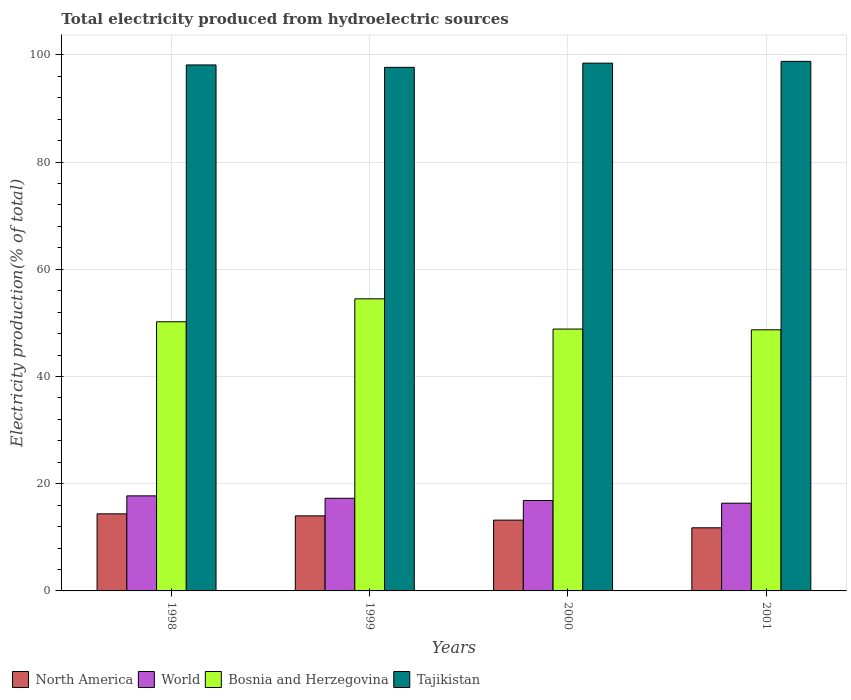How many different coloured bars are there?
Provide a succinct answer. 4. How many groups of bars are there?
Offer a very short reply. 4. How many bars are there on the 1st tick from the left?
Keep it short and to the point. 4. How many bars are there on the 1st tick from the right?
Your answer should be compact. 4. What is the label of the 2nd group of bars from the left?
Make the answer very short. 1999. What is the total electricity produced in Bosnia and Herzegovina in 2001?
Give a very brief answer. 48.7. Across all years, what is the maximum total electricity produced in Tajikistan?
Make the answer very short. 98.78. Across all years, what is the minimum total electricity produced in North America?
Keep it short and to the point. 11.77. What is the total total electricity produced in World in the graph?
Ensure brevity in your answer.  68.24. What is the difference between the total electricity produced in North America in 1999 and that in 2001?
Offer a terse response. 2.23. What is the difference between the total electricity produced in Bosnia and Herzegovina in 1998 and the total electricity produced in North America in 2001?
Provide a succinct answer. 38.43. What is the average total electricity produced in North America per year?
Your response must be concise. 13.34. In the year 1998, what is the difference between the total electricity produced in Bosnia and Herzegovina and total electricity produced in World?
Keep it short and to the point. 32.47. What is the ratio of the total electricity produced in North America in 2000 to that in 2001?
Ensure brevity in your answer.  1.12. Is the total electricity produced in World in 2000 less than that in 2001?
Your answer should be very brief. No. What is the difference between the highest and the second highest total electricity produced in World?
Provide a short and direct response. 0.45. What is the difference between the highest and the lowest total electricity produced in North America?
Keep it short and to the point. 2.6. In how many years, is the total electricity produced in North America greater than the average total electricity produced in North America taken over all years?
Ensure brevity in your answer.  2. Is the sum of the total electricity produced in Bosnia and Herzegovina in 1998 and 2000 greater than the maximum total electricity produced in Tajikistan across all years?
Your answer should be compact. Yes. Is it the case that in every year, the sum of the total electricity produced in Bosnia and Herzegovina and total electricity produced in World is greater than the sum of total electricity produced in North America and total electricity produced in Tajikistan?
Provide a short and direct response. Yes. What does the 4th bar from the left in 2001 represents?
Your answer should be very brief. Tajikistan. Are all the bars in the graph horizontal?
Make the answer very short. No. How many years are there in the graph?
Offer a very short reply. 4. What is the difference between two consecutive major ticks on the Y-axis?
Make the answer very short. 20. Does the graph contain grids?
Give a very brief answer. Yes. What is the title of the graph?
Provide a short and direct response. Total electricity produced from hydroelectric sources. Does "Iraq" appear as one of the legend labels in the graph?
Make the answer very short. No. What is the Electricity production(% of total) of North America in 1998?
Provide a succinct answer. 14.38. What is the Electricity production(% of total) in World in 1998?
Give a very brief answer. 17.73. What is the Electricity production(% of total) of Bosnia and Herzegovina in 1998?
Provide a succinct answer. 50.2. What is the Electricity production(% of total) in Tajikistan in 1998?
Provide a succinct answer. 98.11. What is the Electricity production(% of total) in North America in 1999?
Provide a short and direct response. 14. What is the Electricity production(% of total) of World in 1999?
Provide a succinct answer. 17.28. What is the Electricity production(% of total) in Bosnia and Herzegovina in 1999?
Your answer should be very brief. 54.48. What is the Electricity production(% of total) of Tajikistan in 1999?
Give a very brief answer. 97.66. What is the Electricity production(% of total) in North America in 2000?
Offer a terse response. 13.2. What is the Electricity production(% of total) in World in 2000?
Your answer should be compact. 16.87. What is the Electricity production(% of total) in Bosnia and Herzegovina in 2000?
Your answer should be compact. 48.84. What is the Electricity production(% of total) of Tajikistan in 2000?
Offer a very short reply. 98.44. What is the Electricity production(% of total) of North America in 2001?
Your answer should be very brief. 11.77. What is the Electricity production(% of total) of World in 2001?
Keep it short and to the point. 16.36. What is the Electricity production(% of total) of Bosnia and Herzegovina in 2001?
Offer a terse response. 48.7. What is the Electricity production(% of total) of Tajikistan in 2001?
Ensure brevity in your answer.  98.78. Across all years, what is the maximum Electricity production(% of total) of North America?
Offer a very short reply. 14.38. Across all years, what is the maximum Electricity production(% of total) of World?
Your answer should be very brief. 17.73. Across all years, what is the maximum Electricity production(% of total) of Bosnia and Herzegovina?
Your answer should be very brief. 54.48. Across all years, what is the maximum Electricity production(% of total) in Tajikistan?
Provide a succinct answer. 98.78. Across all years, what is the minimum Electricity production(% of total) in North America?
Ensure brevity in your answer.  11.77. Across all years, what is the minimum Electricity production(% of total) of World?
Ensure brevity in your answer.  16.36. Across all years, what is the minimum Electricity production(% of total) of Bosnia and Herzegovina?
Provide a succinct answer. 48.7. Across all years, what is the minimum Electricity production(% of total) in Tajikistan?
Provide a short and direct response. 97.66. What is the total Electricity production(% of total) of North America in the graph?
Your answer should be compact. 53.35. What is the total Electricity production(% of total) of World in the graph?
Make the answer very short. 68.24. What is the total Electricity production(% of total) of Bosnia and Herzegovina in the graph?
Provide a succinct answer. 202.23. What is the total Electricity production(% of total) in Tajikistan in the graph?
Make the answer very short. 392.98. What is the difference between the Electricity production(% of total) of North America in 1998 and that in 1999?
Offer a terse response. 0.38. What is the difference between the Electricity production(% of total) in World in 1998 and that in 1999?
Offer a very short reply. 0.45. What is the difference between the Electricity production(% of total) in Bosnia and Herzegovina in 1998 and that in 1999?
Give a very brief answer. -4.28. What is the difference between the Electricity production(% of total) of Tajikistan in 1998 and that in 1999?
Your answer should be very brief. 0.45. What is the difference between the Electricity production(% of total) in North America in 1998 and that in 2000?
Offer a very short reply. 1.17. What is the difference between the Electricity production(% of total) in World in 1998 and that in 2000?
Give a very brief answer. 0.86. What is the difference between the Electricity production(% of total) of Bosnia and Herzegovina in 1998 and that in 2000?
Provide a succinct answer. 1.36. What is the difference between the Electricity production(% of total) in Tajikistan in 1998 and that in 2000?
Keep it short and to the point. -0.33. What is the difference between the Electricity production(% of total) in North America in 1998 and that in 2001?
Offer a very short reply. 2.6. What is the difference between the Electricity production(% of total) of World in 1998 and that in 2001?
Your answer should be very brief. 1.37. What is the difference between the Electricity production(% of total) of Bosnia and Herzegovina in 1998 and that in 2001?
Ensure brevity in your answer.  1.5. What is the difference between the Electricity production(% of total) in Tajikistan in 1998 and that in 2001?
Make the answer very short. -0.67. What is the difference between the Electricity production(% of total) in North America in 1999 and that in 2000?
Provide a succinct answer. 0.8. What is the difference between the Electricity production(% of total) in World in 1999 and that in 2000?
Keep it short and to the point. 0.41. What is the difference between the Electricity production(% of total) of Bosnia and Herzegovina in 1999 and that in 2000?
Provide a short and direct response. 5.64. What is the difference between the Electricity production(% of total) in Tajikistan in 1999 and that in 2000?
Provide a succinct answer. -0.78. What is the difference between the Electricity production(% of total) of North America in 1999 and that in 2001?
Ensure brevity in your answer.  2.23. What is the difference between the Electricity production(% of total) of World in 1999 and that in 2001?
Provide a succinct answer. 0.92. What is the difference between the Electricity production(% of total) of Bosnia and Herzegovina in 1999 and that in 2001?
Offer a very short reply. 5.78. What is the difference between the Electricity production(% of total) in Tajikistan in 1999 and that in 2001?
Provide a short and direct response. -1.12. What is the difference between the Electricity production(% of total) of North America in 2000 and that in 2001?
Your answer should be compact. 1.43. What is the difference between the Electricity production(% of total) in World in 2000 and that in 2001?
Give a very brief answer. 0.5. What is the difference between the Electricity production(% of total) in Bosnia and Herzegovina in 2000 and that in 2001?
Offer a very short reply. 0.14. What is the difference between the Electricity production(% of total) in Tajikistan in 2000 and that in 2001?
Offer a very short reply. -0.33. What is the difference between the Electricity production(% of total) in North America in 1998 and the Electricity production(% of total) in World in 1999?
Keep it short and to the point. -2.9. What is the difference between the Electricity production(% of total) of North America in 1998 and the Electricity production(% of total) of Bosnia and Herzegovina in 1999?
Your answer should be compact. -40.1. What is the difference between the Electricity production(% of total) of North America in 1998 and the Electricity production(% of total) of Tajikistan in 1999?
Make the answer very short. -83.28. What is the difference between the Electricity production(% of total) of World in 1998 and the Electricity production(% of total) of Bosnia and Herzegovina in 1999?
Provide a succinct answer. -36.75. What is the difference between the Electricity production(% of total) in World in 1998 and the Electricity production(% of total) in Tajikistan in 1999?
Keep it short and to the point. -79.93. What is the difference between the Electricity production(% of total) of Bosnia and Herzegovina in 1998 and the Electricity production(% of total) of Tajikistan in 1999?
Keep it short and to the point. -47.45. What is the difference between the Electricity production(% of total) in North America in 1998 and the Electricity production(% of total) in World in 2000?
Your response must be concise. -2.49. What is the difference between the Electricity production(% of total) in North America in 1998 and the Electricity production(% of total) in Bosnia and Herzegovina in 2000?
Keep it short and to the point. -34.47. What is the difference between the Electricity production(% of total) in North America in 1998 and the Electricity production(% of total) in Tajikistan in 2000?
Keep it short and to the point. -84.06. What is the difference between the Electricity production(% of total) of World in 1998 and the Electricity production(% of total) of Bosnia and Herzegovina in 2000?
Ensure brevity in your answer.  -31.12. What is the difference between the Electricity production(% of total) in World in 1998 and the Electricity production(% of total) in Tajikistan in 2000?
Offer a very short reply. -80.71. What is the difference between the Electricity production(% of total) of Bosnia and Herzegovina in 1998 and the Electricity production(% of total) of Tajikistan in 2000?
Offer a terse response. -48.24. What is the difference between the Electricity production(% of total) in North America in 1998 and the Electricity production(% of total) in World in 2001?
Ensure brevity in your answer.  -1.99. What is the difference between the Electricity production(% of total) in North America in 1998 and the Electricity production(% of total) in Bosnia and Herzegovina in 2001?
Your answer should be compact. -34.33. What is the difference between the Electricity production(% of total) in North America in 1998 and the Electricity production(% of total) in Tajikistan in 2001?
Make the answer very short. -84.4. What is the difference between the Electricity production(% of total) in World in 1998 and the Electricity production(% of total) in Bosnia and Herzegovina in 2001?
Keep it short and to the point. -30.97. What is the difference between the Electricity production(% of total) in World in 1998 and the Electricity production(% of total) in Tajikistan in 2001?
Make the answer very short. -81.05. What is the difference between the Electricity production(% of total) of Bosnia and Herzegovina in 1998 and the Electricity production(% of total) of Tajikistan in 2001?
Your response must be concise. -48.57. What is the difference between the Electricity production(% of total) in North America in 1999 and the Electricity production(% of total) in World in 2000?
Ensure brevity in your answer.  -2.86. What is the difference between the Electricity production(% of total) in North America in 1999 and the Electricity production(% of total) in Bosnia and Herzegovina in 2000?
Give a very brief answer. -34.84. What is the difference between the Electricity production(% of total) of North America in 1999 and the Electricity production(% of total) of Tajikistan in 2000?
Offer a very short reply. -84.44. What is the difference between the Electricity production(% of total) in World in 1999 and the Electricity production(% of total) in Bosnia and Herzegovina in 2000?
Your answer should be very brief. -31.57. What is the difference between the Electricity production(% of total) in World in 1999 and the Electricity production(% of total) in Tajikistan in 2000?
Offer a very short reply. -81.16. What is the difference between the Electricity production(% of total) of Bosnia and Herzegovina in 1999 and the Electricity production(% of total) of Tajikistan in 2000?
Make the answer very short. -43.96. What is the difference between the Electricity production(% of total) of North America in 1999 and the Electricity production(% of total) of World in 2001?
Your answer should be very brief. -2.36. What is the difference between the Electricity production(% of total) in North America in 1999 and the Electricity production(% of total) in Bosnia and Herzegovina in 2001?
Offer a very short reply. -34.7. What is the difference between the Electricity production(% of total) of North America in 1999 and the Electricity production(% of total) of Tajikistan in 2001?
Make the answer very short. -84.78. What is the difference between the Electricity production(% of total) in World in 1999 and the Electricity production(% of total) in Bosnia and Herzegovina in 2001?
Ensure brevity in your answer.  -31.42. What is the difference between the Electricity production(% of total) of World in 1999 and the Electricity production(% of total) of Tajikistan in 2001?
Your answer should be compact. -81.5. What is the difference between the Electricity production(% of total) of Bosnia and Herzegovina in 1999 and the Electricity production(% of total) of Tajikistan in 2001?
Your answer should be very brief. -44.3. What is the difference between the Electricity production(% of total) of North America in 2000 and the Electricity production(% of total) of World in 2001?
Make the answer very short. -3.16. What is the difference between the Electricity production(% of total) in North America in 2000 and the Electricity production(% of total) in Bosnia and Herzegovina in 2001?
Give a very brief answer. -35.5. What is the difference between the Electricity production(% of total) in North America in 2000 and the Electricity production(% of total) in Tajikistan in 2001?
Your answer should be compact. -85.57. What is the difference between the Electricity production(% of total) of World in 2000 and the Electricity production(% of total) of Bosnia and Herzegovina in 2001?
Your answer should be compact. -31.84. What is the difference between the Electricity production(% of total) in World in 2000 and the Electricity production(% of total) in Tajikistan in 2001?
Offer a terse response. -81.91. What is the difference between the Electricity production(% of total) of Bosnia and Herzegovina in 2000 and the Electricity production(% of total) of Tajikistan in 2001?
Provide a short and direct response. -49.93. What is the average Electricity production(% of total) of North America per year?
Give a very brief answer. 13.34. What is the average Electricity production(% of total) in World per year?
Your answer should be compact. 17.06. What is the average Electricity production(% of total) of Bosnia and Herzegovina per year?
Your response must be concise. 50.56. What is the average Electricity production(% of total) in Tajikistan per year?
Offer a terse response. 98.25. In the year 1998, what is the difference between the Electricity production(% of total) in North America and Electricity production(% of total) in World?
Your answer should be very brief. -3.35. In the year 1998, what is the difference between the Electricity production(% of total) in North America and Electricity production(% of total) in Bosnia and Herzegovina?
Your answer should be very brief. -35.83. In the year 1998, what is the difference between the Electricity production(% of total) in North America and Electricity production(% of total) in Tajikistan?
Give a very brief answer. -83.73. In the year 1998, what is the difference between the Electricity production(% of total) of World and Electricity production(% of total) of Bosnia and Herzegovina?
Provide a succinct answer. -32.47. In the year 1998, what is the difference between the Electricity production(% of total) in World and Electricity production(% of total) in Tajikistan?
Provide a short and direct response. -80.38. In the year 1998, what is the difference between the Electricity production(% of total) of Bosnia and Herzegovina and Electricity production(% of total) of Tajikistan?
Offer a terse response. -47.9. In the year 1999, what is the difference between the Electricity production(% of total) of North America and Electricity production(% of total) of World?
Provide a short and direct response. -3.28. In the year 1999, what is the difference between the Electricity production(% of total) in North America and Electricity production(% of total) in Bosnia and Herzegovina?
Offer a terse response. -40.48. In the year 1999, what is the difference between the Electricity production(% of total) in North America and Electricity production(% of total) in Tajikistan?
Your answer should be compact. -83.66. In the year 1999, what is the difference between the Electricity production(% of total) of World and Electricity production(% of total) of Bosnia and Herzegovina?
Your answer should be very brief. -37.2. In the year 1999, what is the difference between the Electricity production(% of total) of World and Electricity production(% of total) of Tajikistan?
Provide a succinct answer. -80.38. In the year 1999, what is the difference between the Electricity production(% of total) in Bosnia and Herzegovina and Electricity production(% of total) in Tajikistan?
Your answer should be compact. -43.18. In the year 2000, what is the difference between the Electricity production(% of total) of North America and Electricity production(% of total) of World?
Offer a very short reply. -3.66. In the year 2000, what is the difference between the Electricity production(% of total) of North America and Electricity production(% of total) of Bosnia and Herzegovina?
Keep it short and to the point. -35.64. In the year 2000, what is the difference between the Electricity production(% of total) of North America and Electricity production(% of total) of Tajikistan?
Ensure brevity in your answer.  -85.24. In the year 2000, what is the difference between the Electricity production(% of total) in World and Electricity production(% of total) in Bosnia and Herzegovina?
Give a very brief answer. -31.98. In the year 2000, what is the difference between the Electricity production(% of total) in World and Electricity production(% of total) in Tajikistan?
Offer a terse response. -81.58. In the year 2000, what is the difference between the Electricity production(% of total) of Bosnia and Herzegovina and Electricity production(% of total) of Tajikistan?
Provide a succinct answer. -49.6. In the year 2001, what is the difference between the Electricity production(% of total) in North America and Electricity production(% of total) in World?
Your response must be concise. -4.59. In the year 2001, what is the difference between the Electricity production(% of total) of North America and Electricity production(% of total) of Bosnia and Herzegovina?
Make the answer very short. -36.93. In the year 2001, what is the difference between the Electricity production(% of total) in North America and Electricity production(% of total) in Tajikistan?
Your answer should be very brief. -87. In the year 2001, what is the difference between the Electricity production(% of total) in World and Electricity production(% of total) in Bosnia and Herzegovina?
Offer a terse response. -32.34. In the year 2001, what is the difference between the Electricity production(% of total) of World and Electricity production(% of total) of Tajikistan?
Offer a very short reply. -82.41. In the year 2001, what is the difference between the Electricity production(% of total) in Bosnia and Herzegovina and Electricity production(% of total) in Tajikistan?
Your response must be concise. -50.07. What is the ratio of the Electricity production(% of total) in North America in 1998 to that in 1999?
Ensure brevity in your answer.  1.03. What is the ratio of the Electricity production(% of total) of World in 1998 to that in 1999?
Your answer should be very brief. 1.03. What is the ratio of the Electricity production(% of total) of Bosnia and Herzegovina in 1998 to that in 1999?
Your answer should be very brief. 0.92. What is the ratio of the Electricity production(% of total) of North America in 1998 to that in 2000?
Provide a succinct answer. 1.09. What is the ratio of the Electricity production(% of total) in World in 1998 to that in 2000?
Keep it short and to the point. 1.05. What is the ratio of the Electricity production(% of total) in Bosnia and Herzegovina in 1998 to that in 2000?
Provide a short and direct response. 1.03. What is the ratio of the Electricity production(% of total) in North America in 1998 to that in 2001?
Your answer should be very brief. 1.22. What is the ratio of the Electricity production(% of total) in World in 1998 to that in 2001?
Provide a short and direct response. 1.08. What is the ratio of the Electricity production(% of total) in Bosnia and Herzegovina in 1998 to that in 2001?
Give a very brief answer. 1.03. What is the ratio of the Electricity production(% of total) in Tajikistan in 1998 to that in 2001?
Ensure brevity in your answer.  0.99. What is the ratio of the Electricity production(% of total) of North America in 1999 to that in 2000?
Your answer should be very brief. 1.06. What is the ratio of the Electricity production(% of total) of World in 1999 to that in 2000?
Your answer should be compact. 1.02. What is the ratio of the Electricity production(% of total) of Bosnia and Herzegovina in 1999 to that in 2000?
Make the answer very short. 1.12. What is the ratio of the Electricity production(% of total) of Tajikistan in 1999 to that in 2000?
Keep it short and to the point. 0.99. What is the ratio of the Electricity production(% of total) of North America in 1999 to that in 2001?
Your answer should be very brief. 1.19. What is the ratio of the Electricity production(% of total) in World in 1999 to that in 2001?
Offer a terse response. 1.06. What is the ratio of the Electricity production(% of total) in Bosnia and Herzegovina in 1999 to that in 2001?
Make the answer very short. 1.12. What is the ratio of the Electricity production(% of total) in Tajikistan in 1999 to that in 2001?
Make the answer very short. 0.99. What is the ratio of the Electricity production(% of total) of North America in 2000 to that in 2001?
Your answer should be compact. 1.12. What is the ratio of the Electricity production(% of total) of World in 2000 to that in 2001?
Offer a terse response. 1.03. What is the ratio of the Electricity production(% of total) of Tajikistan in 2000 to that in 2001?
Your answer should be very brief. 1. What is the difference between the highest and the second highest Electricity production(% of total) of North America?
Make the answer very short. 0.38. What is the difference between the highest and the second highest Electricity production(% of total) of World?
Offer a very short reply. 0.45. What is the difference between the highest and the second highest Electricity production(% of total) of Bosnia and Herzegovina?
Offer a very short reply. 4.28. What is the difference between the highest and the second highest Electricity production(% of total) in Tajikistan?
Your answer should be compact. 0.33. What is the difference between the highest and the lowest Electricity production(% of total) in North America?
Ensure brevity in your answer.  2.6. What is the difference between the highest and the lowest Electricity production(% of total) in World?
Provide a short and direct response. 1.37. What is the difference between the highest and the lowest Electricity production(% of total) in Bosnia and Herzegovina?
Provide a succinct answer. 5.78. What is the difference between the highest and the lowest Electricity production(% of total) in Tajikistan?
Make the answer very short. 1.12. 